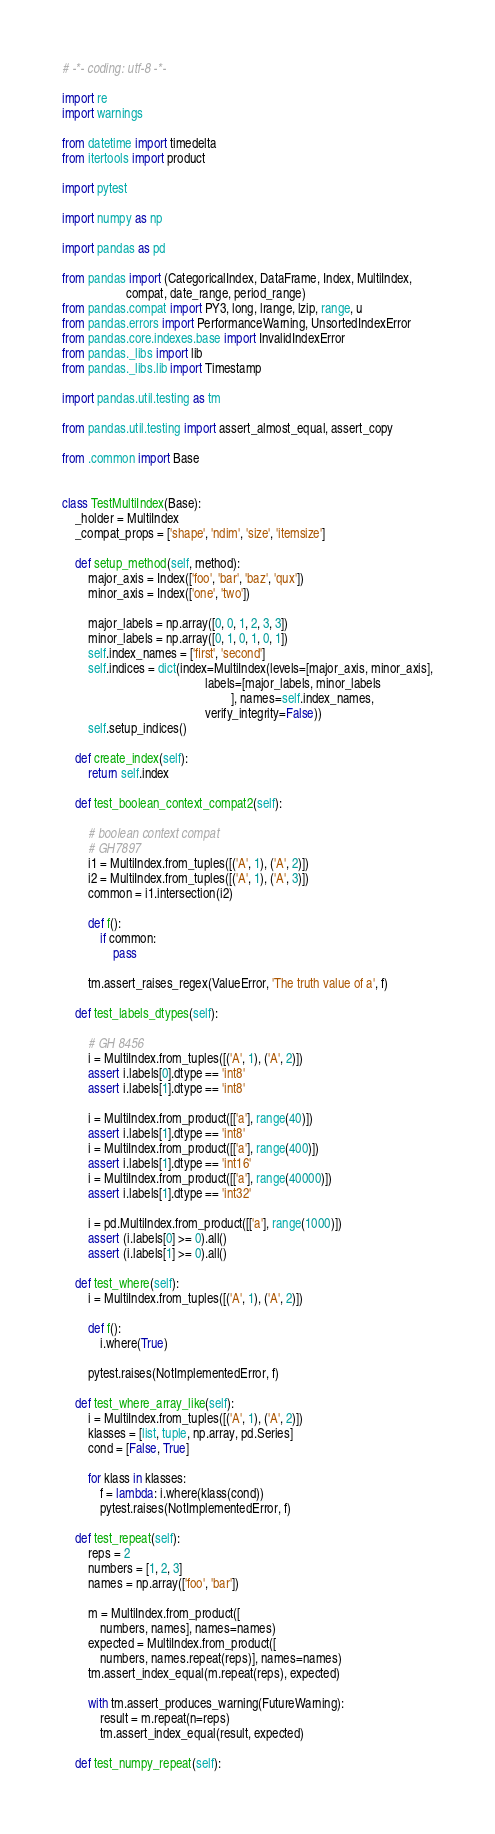<code> <loc_0><loc_0><loc_500><loc_500><_Python_># -*- coding: utf-8 -*-

import re
import warnings

from datetime import timedelta
from itertools import product

import pytest

import numpy as np

import pandas as pd

from pandas import (CategoricalIndex, DataFrame, Index, MultiIndex,
                    compat, date_range, period_range)
from pandas.compat import PY3, long, lrange, lzip, range, u
from pandas.errors import PerformanceWarning, UnsortedIndexError
from pandas.core.indexes.base import InvalidIndexError
from pandas._libs import lib
from pandas._libs.lib import Timestamp

import pandas.util.testing as tm

from pandas.util.testing import assert_almost_equal, assert_copy

from .common import Base


class TestMultiIndex(Base):
    _holder = MultiIndex
    _compat_props = ['shape', 'ndim', 'size', 'itemsize']

    def setup_method(self, method):
        major_axis = Index(['foo', 'bar', 'baz', 'qux'])
        minor_axis = Index(['one', 'two'])

        major_labels = np.array([0, 0, 1, 2, 3, 3])
        minor_labels = np.array([0, 1, 0, 1, 0, 1])
        self.index_names = ['first', 'second']
        self.indices = dict(index=MultiIndex(levels=[major_axis, minor_axis],
                                             labels=[major_labels, minor_labels
                                                     ], names=self.index_names,
                                             verify_integrity=False))
        self.setup_indices()

    def create_index(self):
        return self.index

    def test_boolean_context_compat2(self):

        # boolean context compat
        # GH7897
        i1 = MultiIndex.from_tuples([('A', 1), ('A', 2)])
        i2 = MultiIndex.from_tuples([('A', 1), ('A', 3)])
        common = i1.intersection(i2)

        def f():
            if common:
                pass

        tm.assert_raises_regex(ValueError, 'The truth value of a', f)

    def test_labels_dtypes(self):

        # GH 8456
        i = MultiIndex.from_tuples([('A', 1), ('A', 2)])
        assert i.labels[0].dtype == 'int8'
        assert i.labels[1].dtype == 'int8'

        i = MultiIndex.from_product([['a'], range(40)])
        assert i.labels[1].dtype == 'int8'
        i = MultiIndex.from_product([['a'], range(400)])
        assert i.labels[1].dtype == 'int16'
        i = MultiIndex.from_product([['a'], range(40000)])
        assert i.labels[1].dtype == 'int32'

        i = pd.MultiIndex.from_product([['a'], range(1000)])
        assert (i.labels[0] >= 0).all()
        assert (i.labels[1] >= 0).all()

    def test_where(self):
        i = MultiIndex.from_tuples([('A', 1), ('A', 2)])

        def f():
            i.where(True)

        pytest.raises(NotImplementedError, f)

    def test_where_array_like(self):
        i = MultiIndex.from_tuples([('A', 1), ('A', 2)])
        klasses = [list, tuple, np.array, pd.Series]
        cond = [False, True]

        for klass in klasses:
            f = lambda: i.where(klass(cond))
            pytest.raises(NotImplementedError, f)

    def test_repeat(self):
        reps = 2
        numbers = [1, 2, 3]
        names = np.array(['foo', 'bar'])

        m = MultiIndex.from_product([
            numbers, names], names=names)
        expected = MultiIndex.from_product([
            numbers, names.repeat(reps)], names=names)
        tm.assert_index_equal(m.repeat(reps), expected)

        with tm.assert_produces_warning(FutureWarning):
            result = m.repeat(n=reps)
            tm.assert_index_equal(result, expected)

    def test_numpy_repeat(self):</code> 